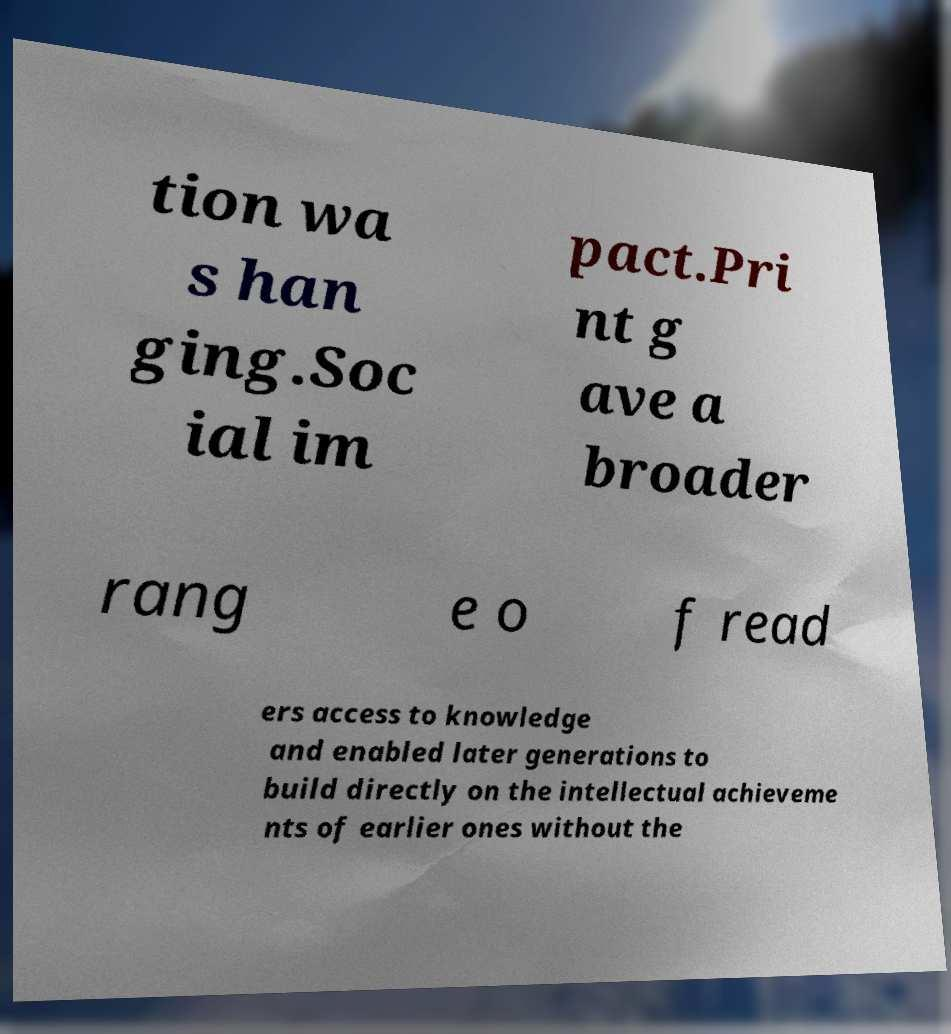For documentation purposes, I need the text within this image transcribed. Could you provide that? tion wa s han ging.Soc ial im pact.Pri nt g ave a broader rang e o f read ers access to knowledge and enabled later generations to build directly on the intellectual achieveme nts of earlier ones without the 